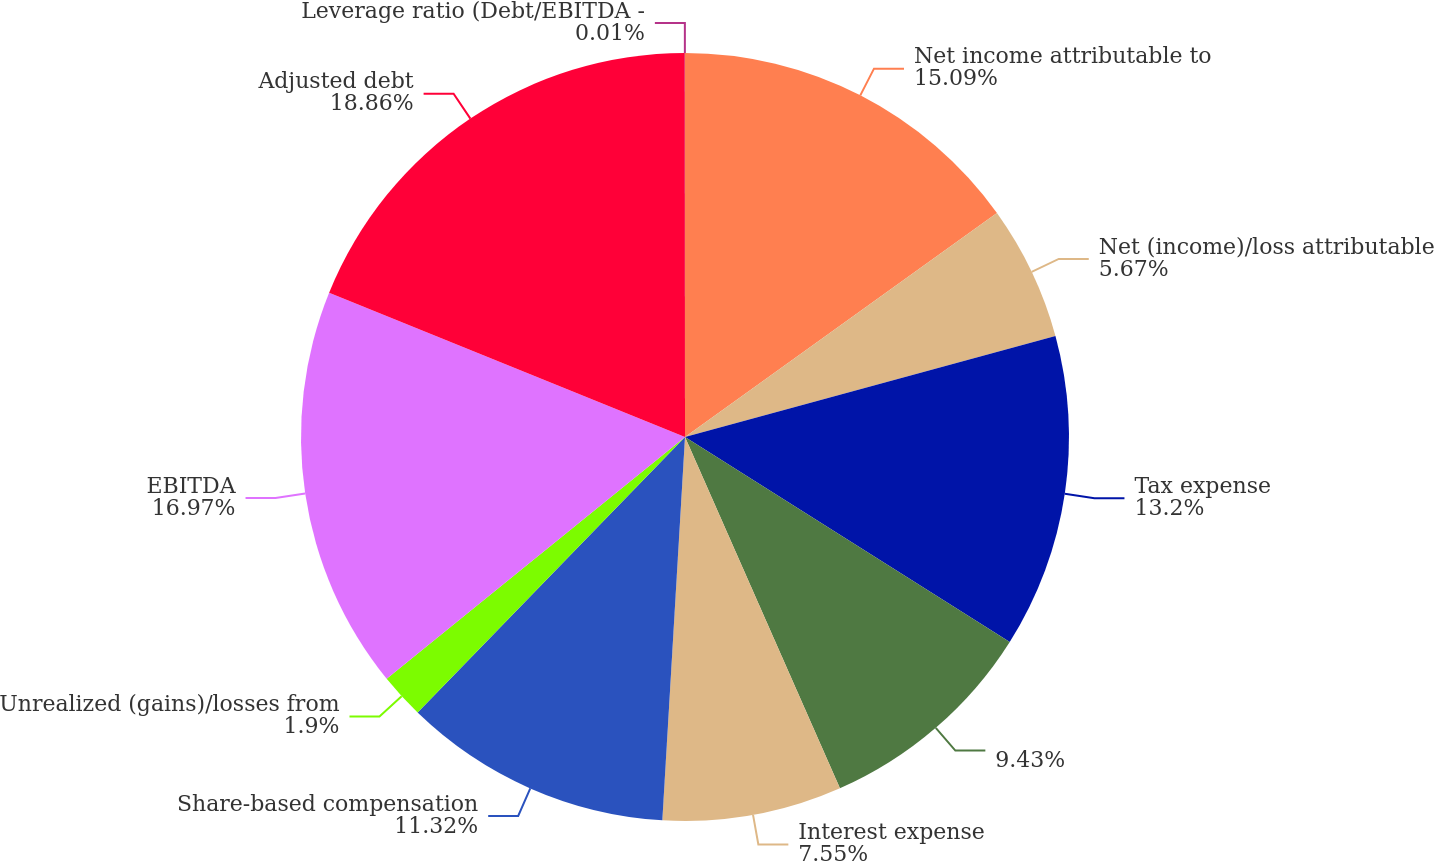<chart> <loc_0><loc_0><loc_500><loc_500><pie_chart><fcel>Net income attributable to<fcel>Net (income)/loss attributable<fcel>Tax expense<fcel>Unnamed: 3<fcel>Interest expense<fcel>Share-based compensation<fcel>Unrealized (gains)/losses from<fcel>EBITDA<fcel>Adjusted debt<fcel>Leverage ratio (Debt/EBITDA -<nl><fcel>15.09%<fcel>5.67%<fcel>13.2%<fcel>9.43%<fcel>7.55%<fcel>11.32%<fcel>1.9%<fcel>16.97%<fcel>18.86%<fcel>0.01%<nl></chart> 